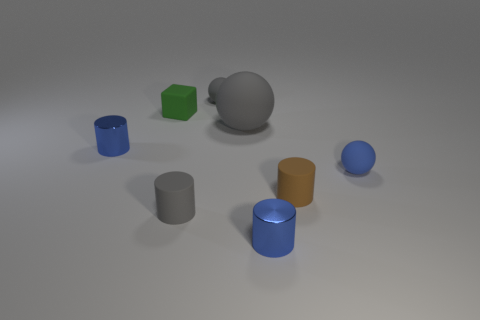Subtract all brown matte cylinders. How many cylinders are left? 3 Add 1 green matte things. How many objects exist? 9 Subtract all brown cylinders. How many cylinders are left? 3 Subtract all balls. How many objects are left? 5 Subtract all large rubber objects. Subtract all green things. How many objects are left? 6 Add 4 blue balls. How many blue balls are left? 5 Add 8 small brown rubber cylinders. How many small brown rubber cylinders exist? 9 Subtract 0 purple cylinders. How many objects are left? 8 Subtract 1 blocks. How many blocks are left? 0 Subtract all purple cubes. Subtract all brown cylinders. How many cubes are left? 1 